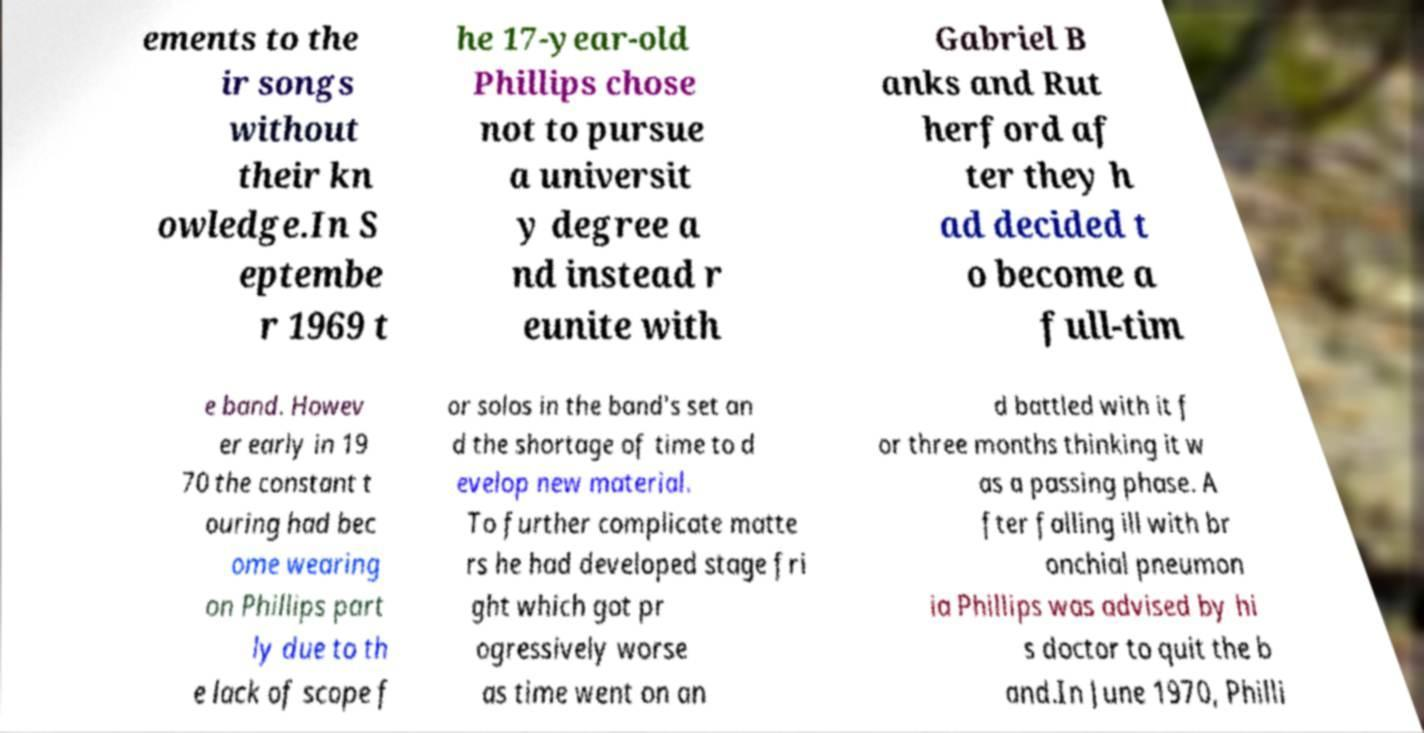Can you accurately transcribe the text from the provided image for me? ements to the ir songs without their kn owledge.In S eptembe r 1969 t he 17-year-old Phillips chose not to pursue a universit y degree a nd instead r eunite with Gabriel B anks and Rut herford af ter they h ad decided t o become a full-tim e band. Howev er early in 19 70 the constant t ouring had bec ome wearing on Phillips part ly due to th e lack of scope f or solos in the band's set an d the shortage of time to d evelop new material. To further complicate matte rs he had developed stage fri ght which got pr ogressively worse as time went on an d battled with it f or three months thinking it w as a passing phase. A fter falling ill with br onchial pneumon ia Phillips was advised by hi s doctor to quit the b and.In June 1970, Philli 